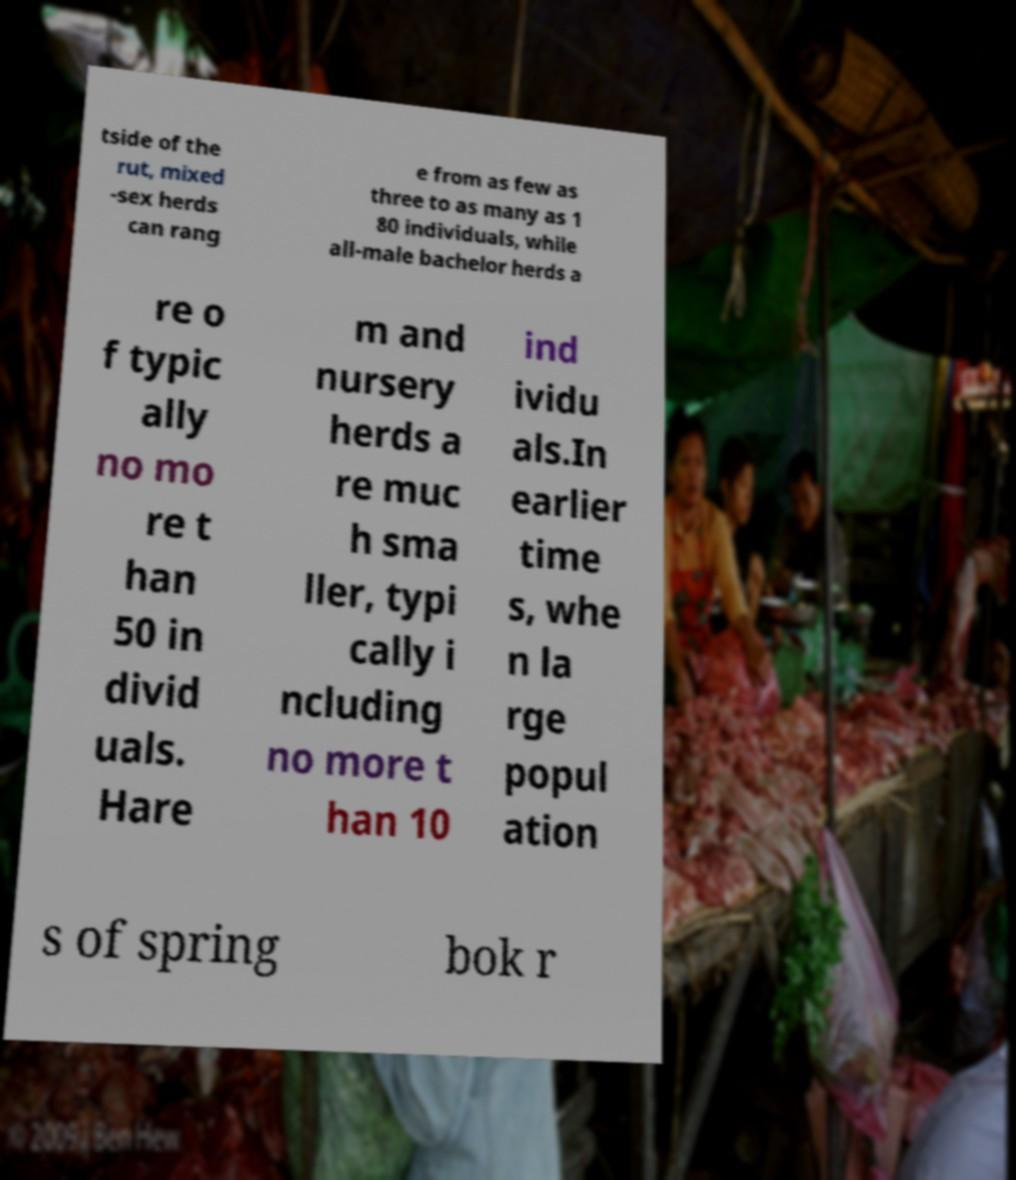Could you assist in decoding the text presented in this image and type it out clearly? tside of the rut, mixed -sex herds can rang e from as few as three to as many as 1 80 individuals, while all-male bachelor herds a re o f typic ally no mo re t han 50 in divid uals. Hare m and nursery herds a re muc h sma ller, typi cally i ncluding no more t han 10 ind ividu als.In earlier time s, whe n la rge popul ation s of spring bok r 